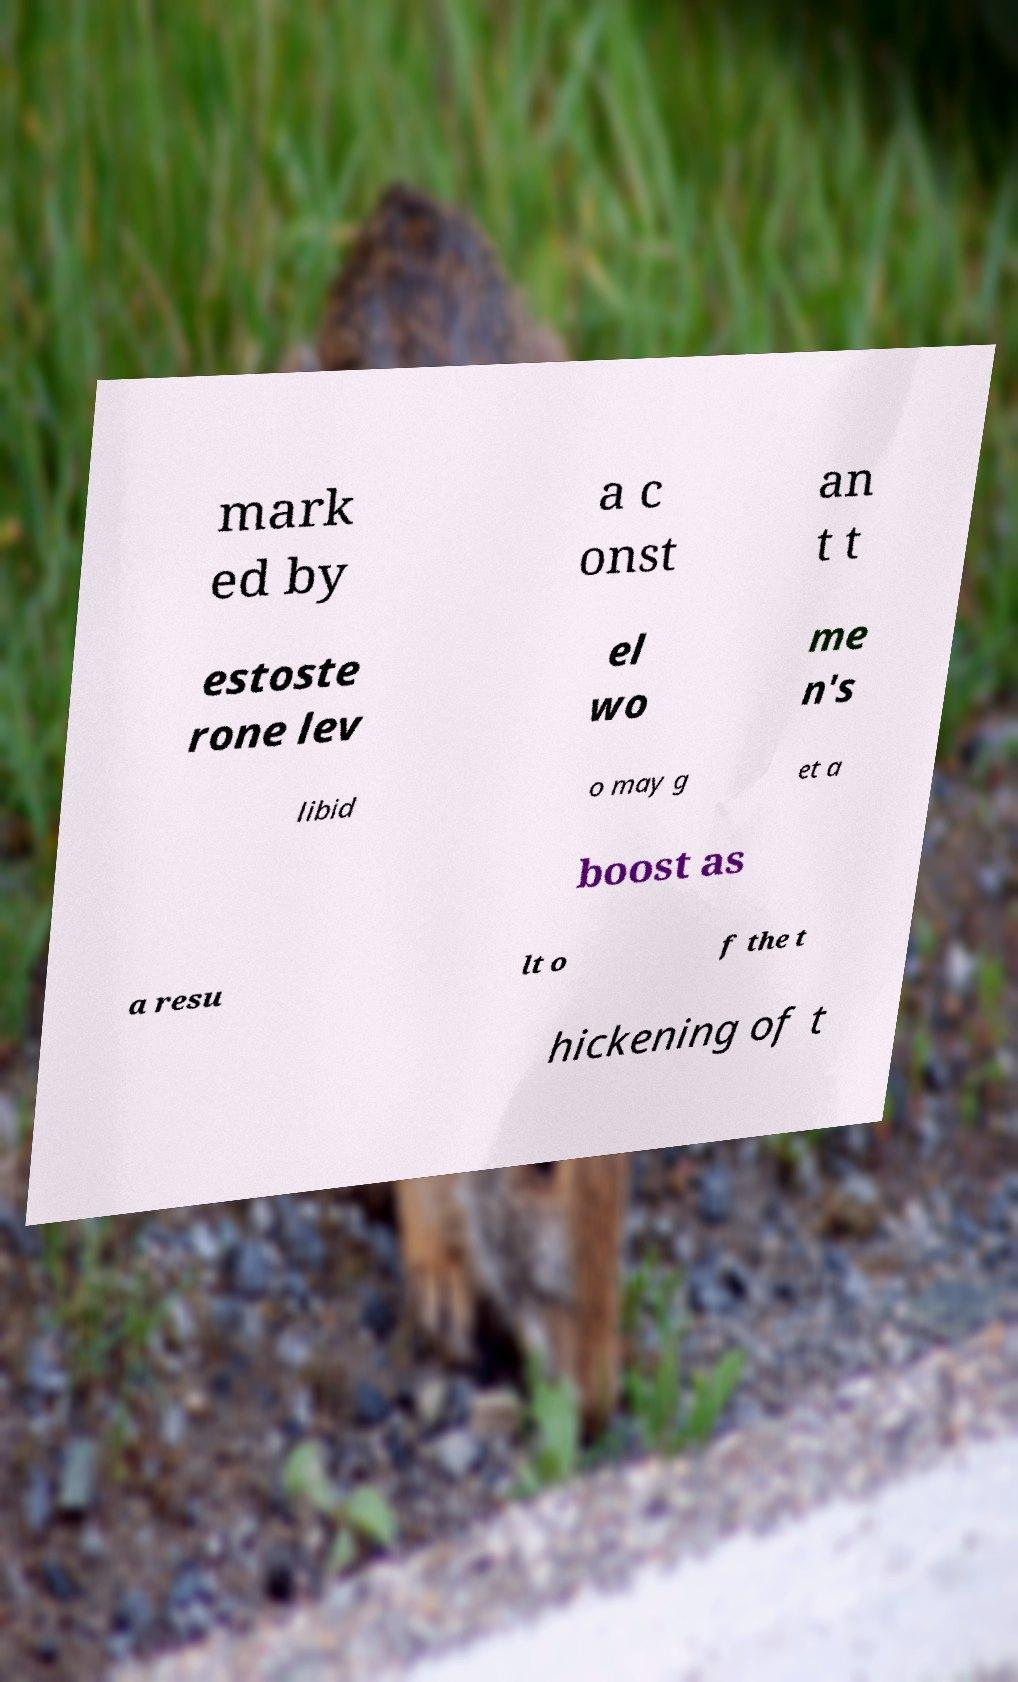Please read and relay the text visible in this image. What does it say? mark ed by a c onst an t t estoste rone lev el wo me n's libid o may g et a boost as a resu lt o f the t hickening of t 